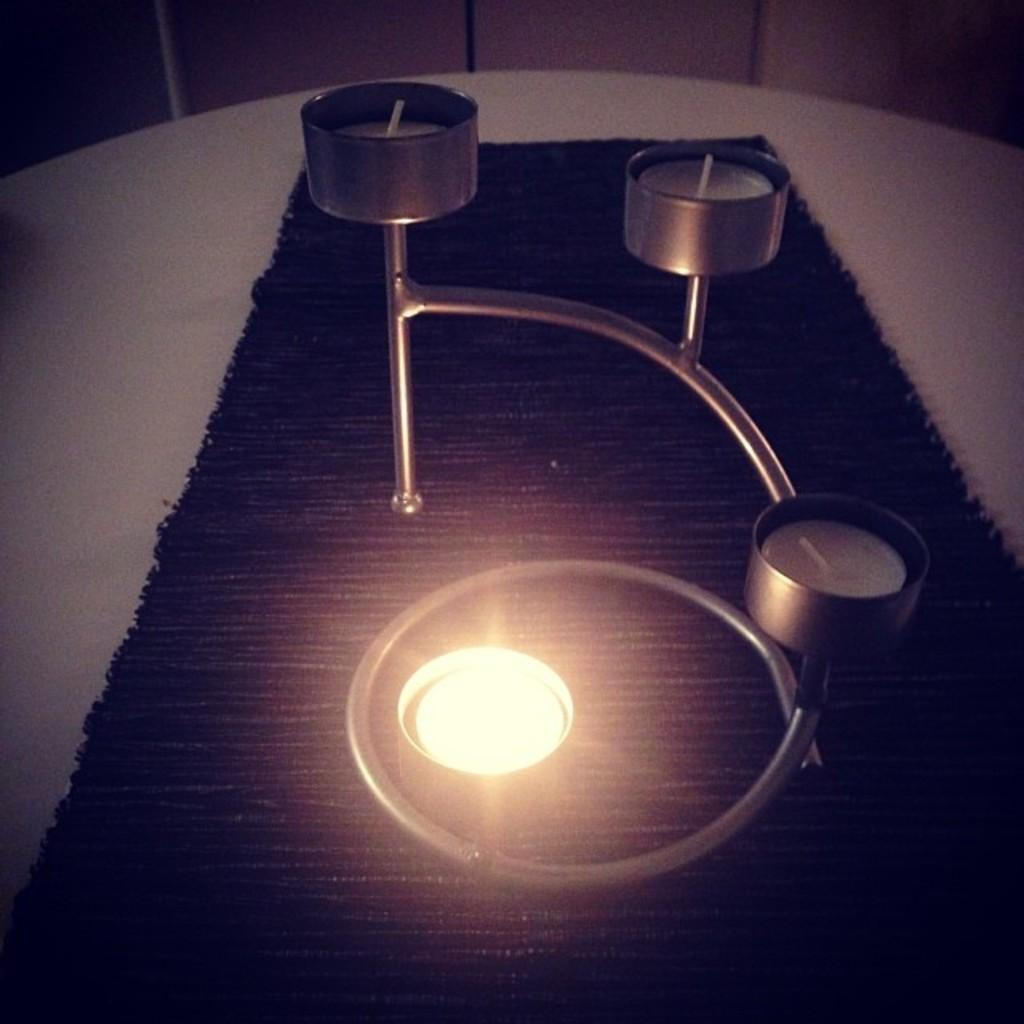What objects are present in the image that hold candles? There are candle stands in the image. How many candles can be seen in the image? There are candles on the candle stands. What is placed under the candle stands? There is a black cloth under the candle stands. Can you see any pencils or wings in the image? No, there are no pencils or wings present in the image. 